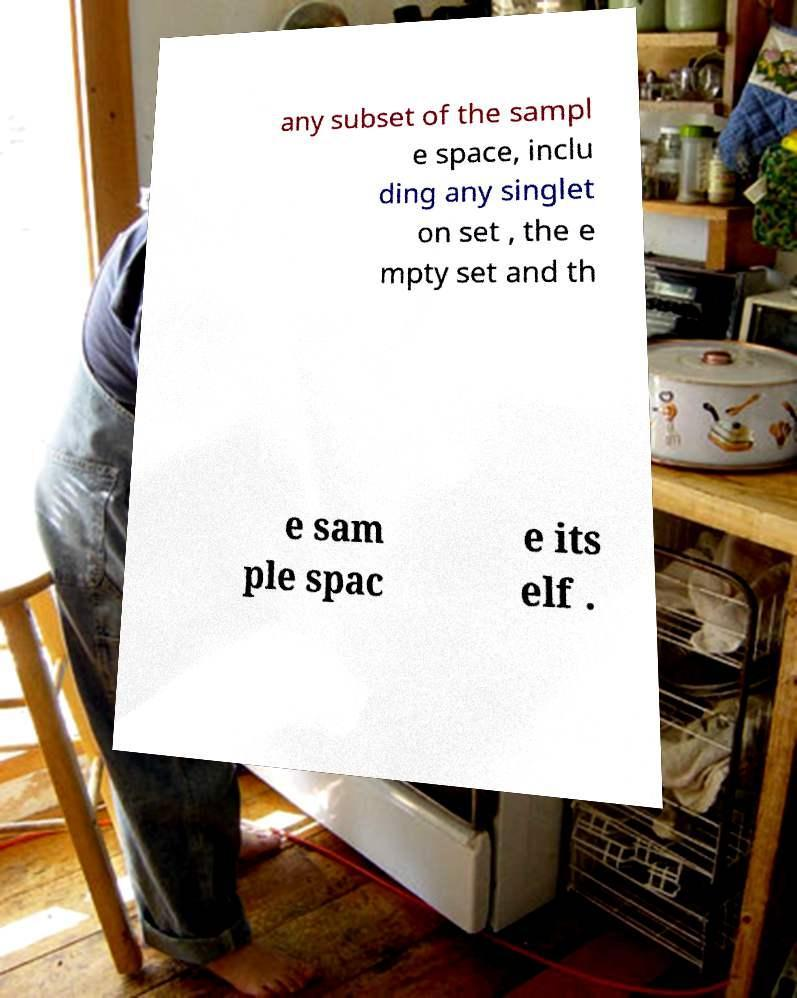Please read and relay the text visible in this image. What does it say? any subset of the sampl e space, inclu ding any singlet on set , the e mpty set and th e sam ple spac e its elf . 